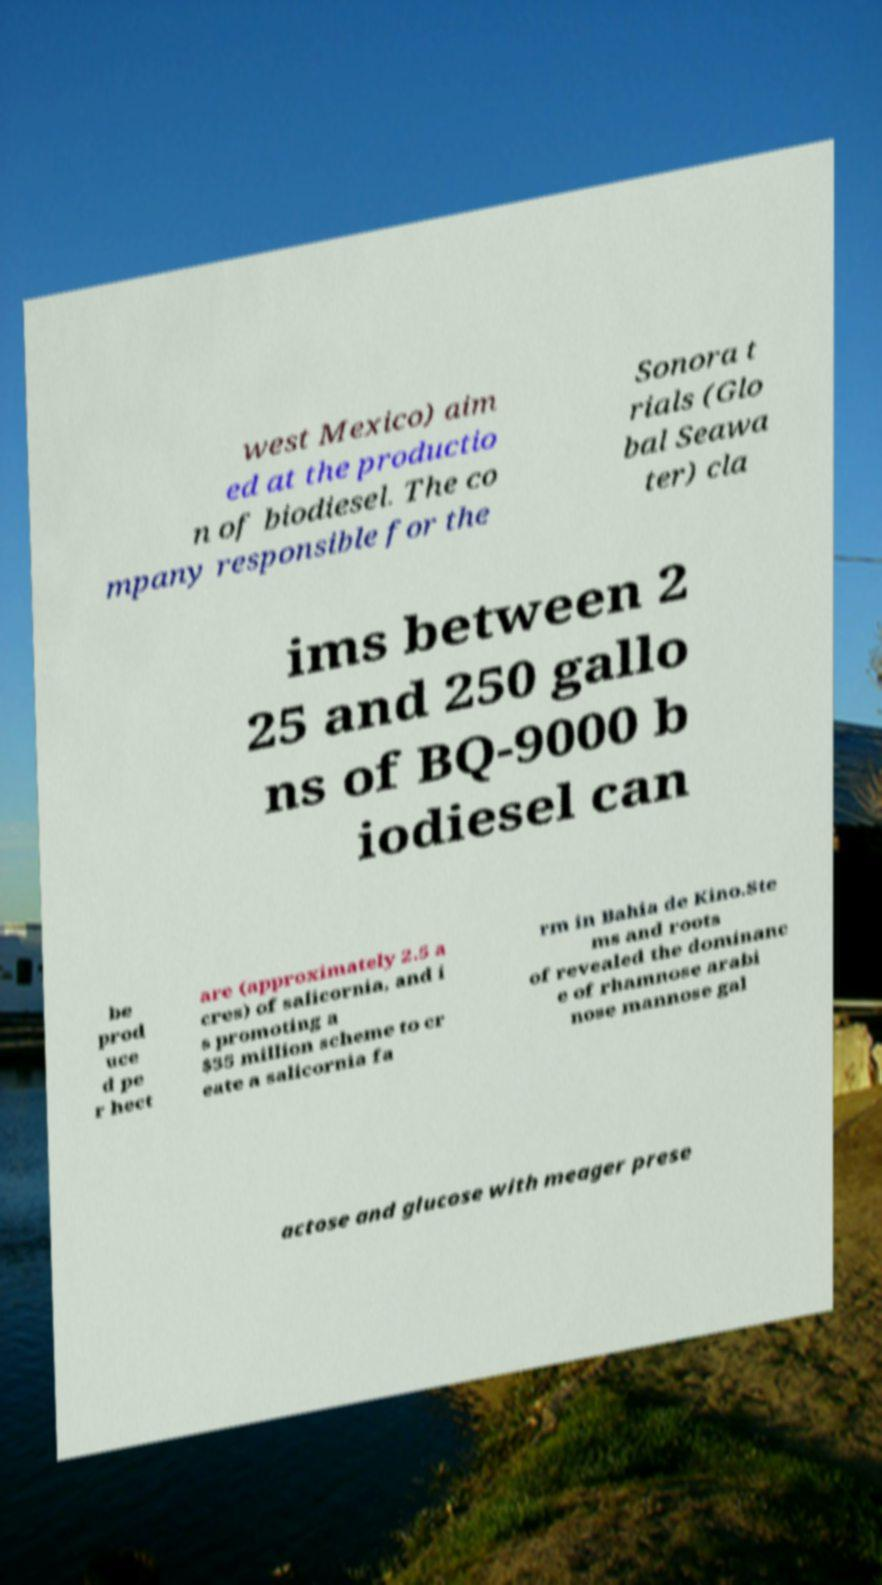What messages or text are displayed in this image? I need them in a readable, typed format. west Mexico) aim ed at the productio n of biodiesel. The co mpany responsible for the Sonora t rials (Glo bal Seawa ter) cla ims between 2 25 and 250 gallo ns of BQ-9000 b iodiesel can be prod uce d pe r hect are (approximately 2.5 a cres) of salicornia, and i s promoting a $35 million scheme to cr eate a salicornia fa rm in Bahia de Kino.Ste ms and roots of revealed the dominanc e of rhamnose arabi nose mannose gal actose and glucose with meager prese 